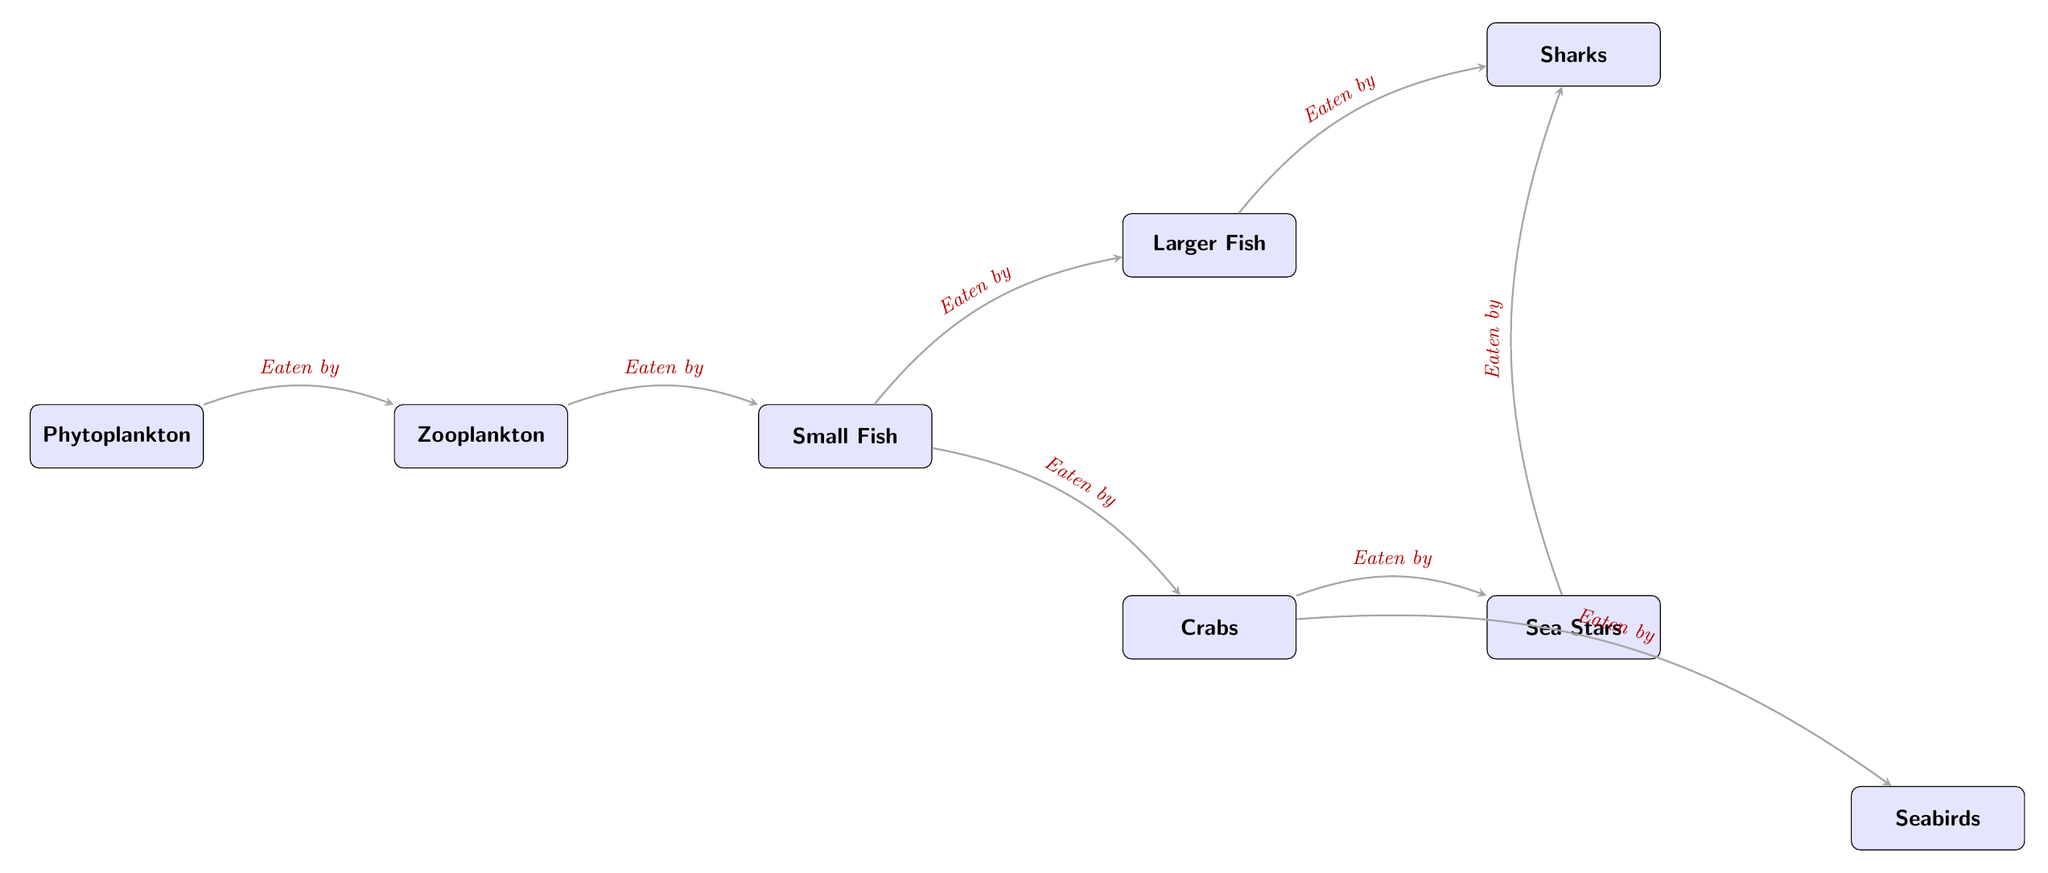What are the primary producers in the diagram? The diagram shows phytoplankton at the starting point, which is the primary producer in this food chain.
Answer: Phytoplankton How many consumers are in the diagram? The diagram has four consumers: zooplankton, small fish, crabs, and larger fish.
Answer: Four What do crabs eat? The diagram indicates that crabs consume small fish as their food source.
Answer: Small fish Which species feeds directly on zooplankton? The relationship depicted in the diagram shows that small fish eat zooplankton directly.
Answer: Small fish What happens to larger fish in the food chain? The diagram illustrates that larger fish are eaten by sharks, showing their role as a prey species.
Answer: Eaten by sharks Which species are at the top of the food chain? The diagram identifies sharks as the apex predators, meaning they are at the top of the food chain.
Answer: Sharks How many species are shown as scavengers? Crabs and sea stars are identified as scavenging species in this food chain.
Answer: Two What type of relationship exists between sea stars and sharks? According to the diagram, sea stars are also prey for sharks, establishing a predation relationship between them.
Answer: Eaten by sharks Which species directly consumes crabs? The diagram specifies that both sea stars and seabirds eat crabs in the food chain.
Answer: Sea stars, seabirds 